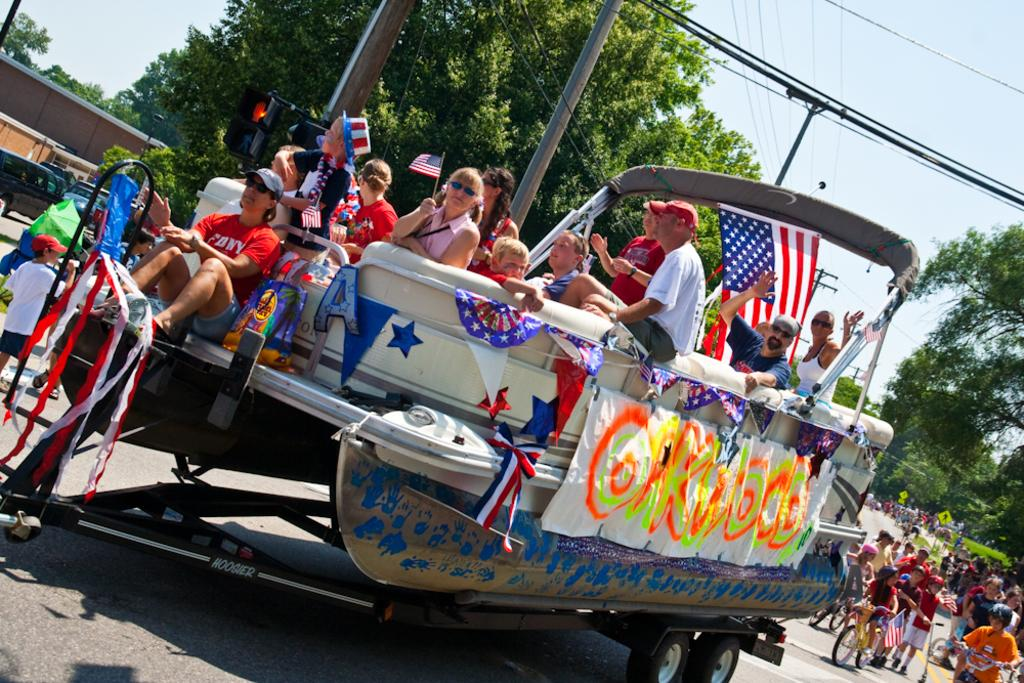<image>
Present a compact description of the photo's key features. A pontoon boat made up like a parade float, with a guy in the back in a red Sony shirt. 